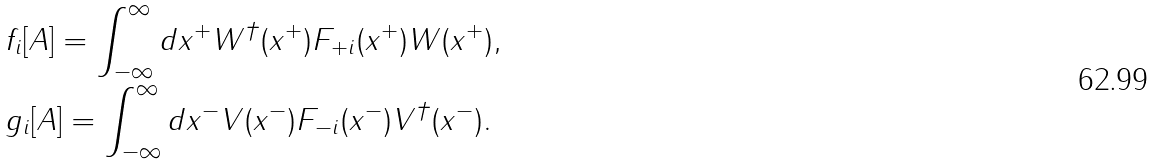Convert formula to latex. <formula><loc_0><loc_0><loc_500><loc_500>& f _ { i } [ A ] = \int _ { - \infty } ^ { \infty } d x ^ { + } W ^ { \dagger } ( x ^ { + } ) F _ { + i } ( x ^ { + } ) W ( x ^ { + } ) , \\ & g _ { i } [ A ] = \int _ { - \infty } ^ { \infty } d x ^ { - } V ( x ^ { - } ) F _ { - i } ( x ^ { - } ) V ^ { \dagger } ( x ^ { - } ) .</formula> 